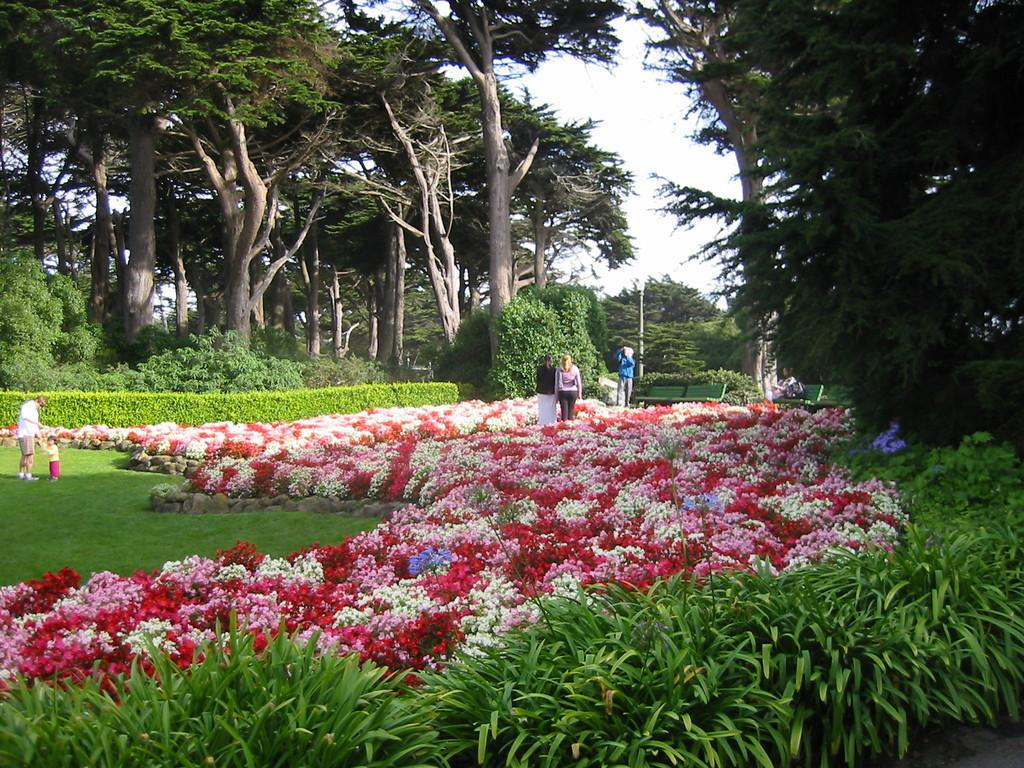What type of outdoor space is depicted in the image? There is a beautiful garden in the image. What types of vegetation can be found in the garden? The garden contains flowers, plants, and trees. Are there any people present in the image? Yes, there are people standing on the grass in the image. How many dolls are sitting on the yak in the image? There are no dolls or yaks present in the image; it features a beautiful garden with flowers, plants, trees, and people standing on the grass. 